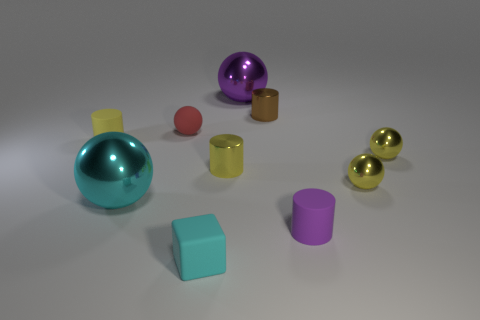Subtract 1 cylinders. How many cylinders are left? 3 Subtract all red balls. How many balls are left? 4 Subtract all red matte balls. How many balls are left? 4 Subtract all green spheres. Subtract all blue blocks. How many spheres are left? 5 Subtract all cylinders. How many objects are left? 6 Subtract all yellow metal cylinders. Subtract all yellow rubber cylinders. How many objects are left? 8 Add 9 cyan balls. How many cyan balls are left? 10 Add 4 large red rubber blocks. How many large red rubber blocks exist? 4 Subtract 0 red cubes. How many objects are left? 10 